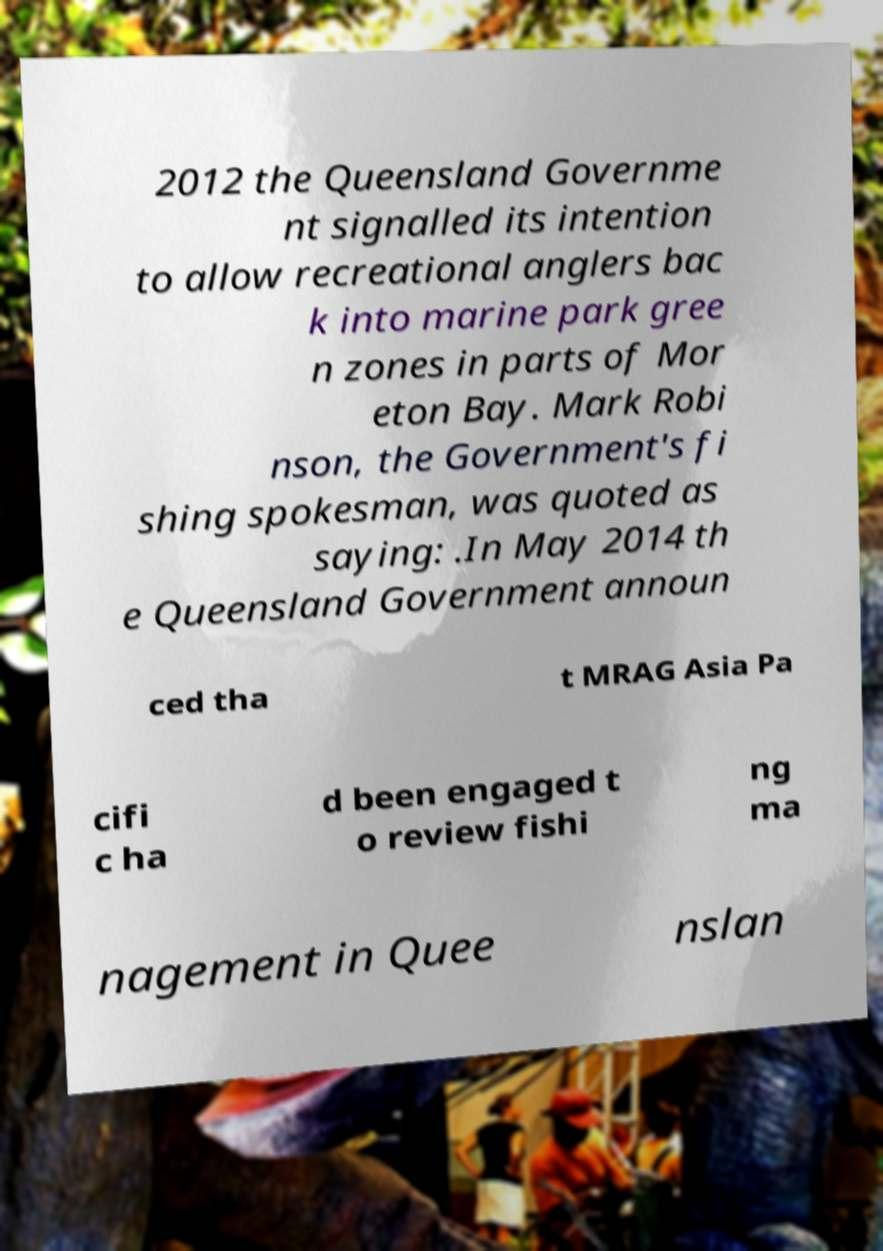I need the written content from this picture converted into text. Can you do that? 2012 the Queensland Governme nt signalled its intention to allow recreational anglers bac k into marine park gree n zones in parts of Mor eton Bay. Mark Robi nson, the Government's fi shing spokesman, was quoted as saying: .In May 2014 th e Queensland Government announ ced tha t MRAG Asia Pa cifi c ha d been engaged t o review fishi ng ma nagement in Quee nslan 